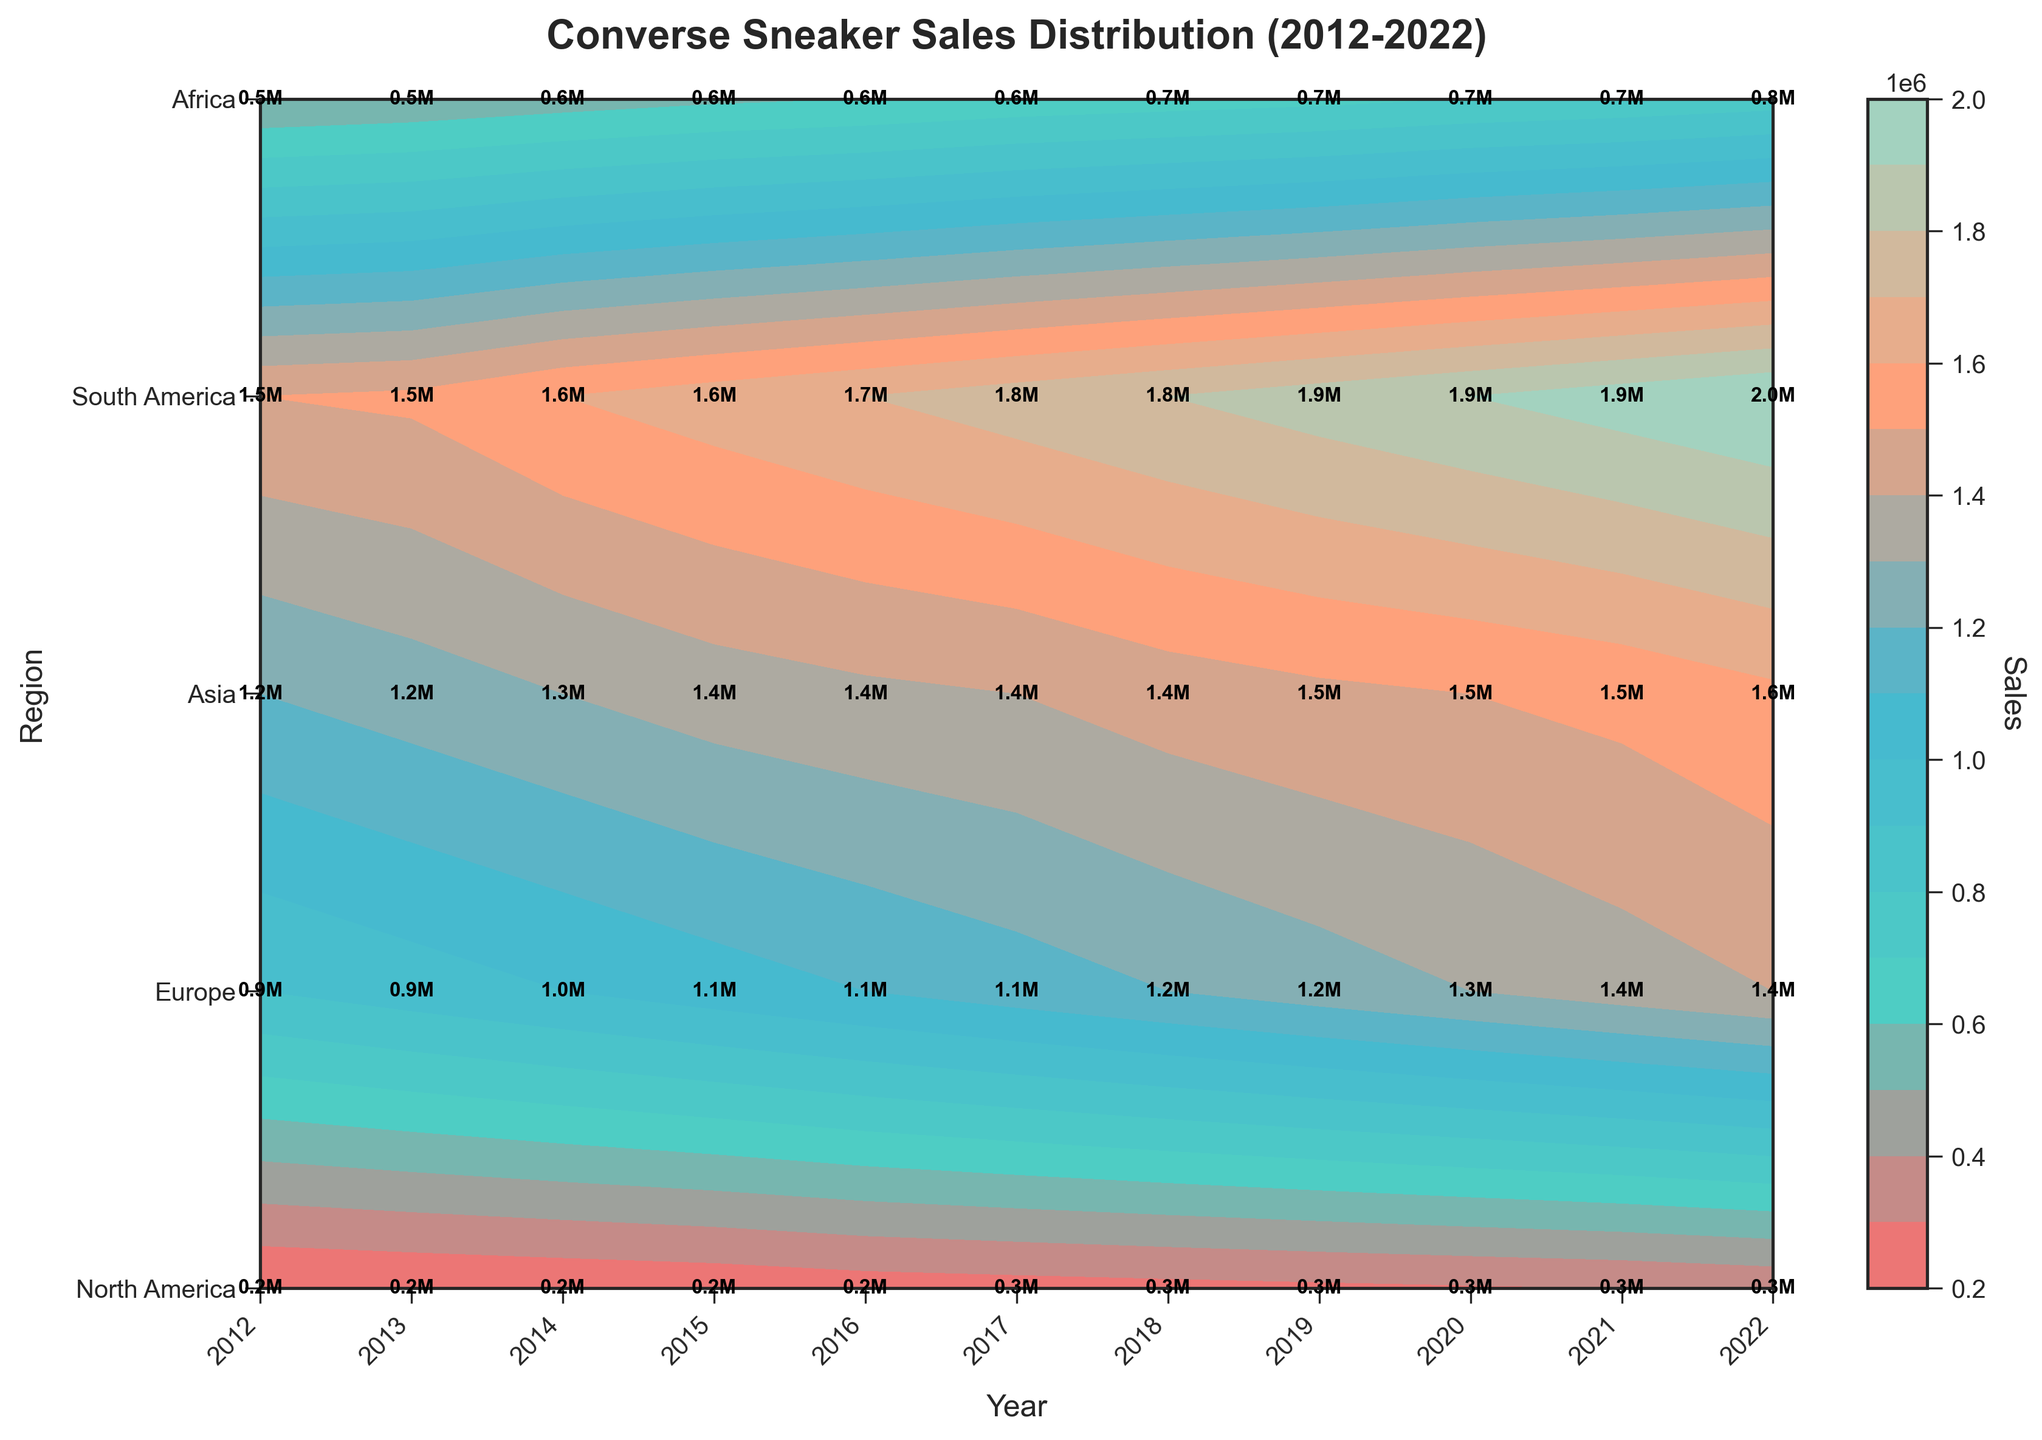How many regions are shown in the figure? The figure has distinct labels along the vertical axis (regions). Counting these labels will reveal the number of regions displayed.
Answer: 5 What is the overall title of the figure? The title is usually located at the top of the figure and provides a summary of what the graph represents.
Answer: Converse Sneaker Sales Distribution (2012-2022) Which year saw the highest sales in North America? By locating the region "North America" on the vertical axis and looking across the years on the horizontal axis, the sales values can be compared to determine the highest.
Answer: 2022 What were the sales for Asia in 2018? Locate the intersection of the 'Asia' row with the '2018' column to find the corresponding sales value.
Answer: 1200000 Between which two consecutive years did Europe experience the largest increase in sales? By comparing the sales values of each consecutive year for Europe, the largest difference can be identified.
Answer: 2021-2022 How much did the sales in South America increase from 2014 to 2019? Subtract the sales value in South America for 2014 from that in 2019 to find the increase.
Answer: 120000 Which region had the least sales in 2020? By comparing the sales values of all regions for the year 2020, the region with the least sales can be identified.
Answer: Africa How did the sales trend in North America change from 2012 to 2022? By observing the progression of sales values in North America from 2012 through 2022, the trend (increasing or decreasing) can be determined.
Answer: Increasing What is the color gradient associated with higher sales in the figure? By examining the contour plot gradient, the color corresponding to the higher end of the sales value range can be identified.
Answer: Light green to blue Which region had consistent steady growth in sales over the past decade? By examining the sales values trend for each region over the decade, the region with consistent growth patterns can be identified.
Answer: North America 